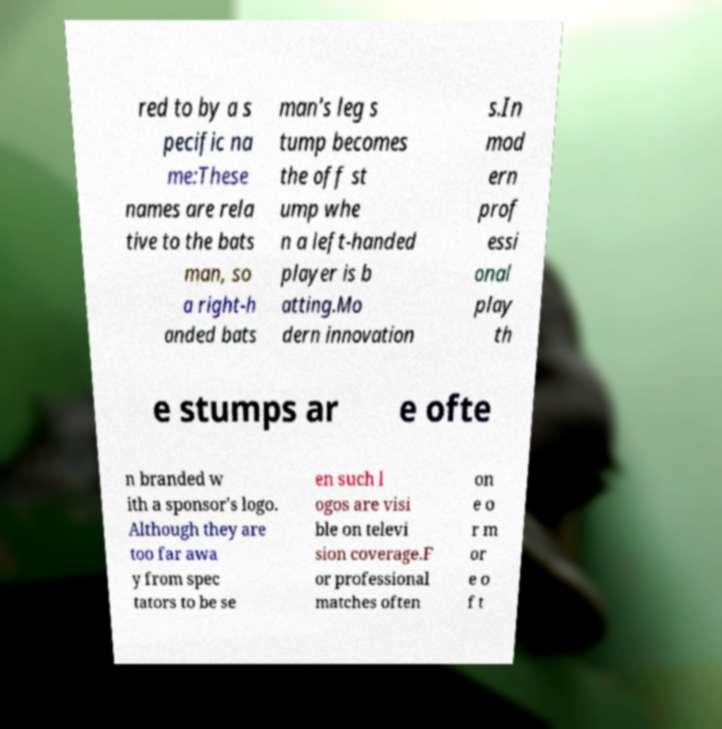There's text embedded in this image that I need extracted. Can you transcribe it verbatim? red to by a s pecific na me:These names are rela tive to the bats man, so a right-h anded bats man's leg s tump becomes the off st ump whe n a left-handed player is b atting.Mo dern innovation s.In mod ern prof essi onal play th e stumps ar e ofte n branded w ith a sponsor's logo. Although they are too far awa y from spec tators to be se en such l ogos are visi ble on televi sion coverage.F or professional matches often on e o r m or e o f t 